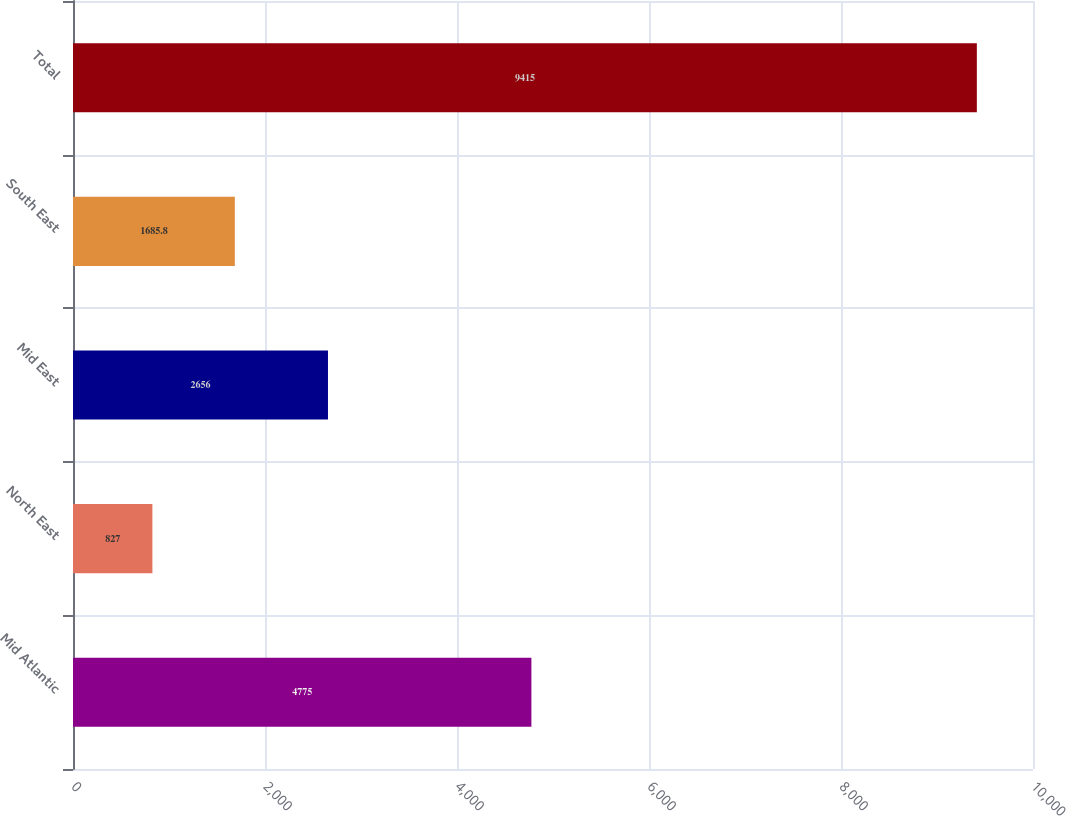Convert chart. <chart><loc_0><loc_0><loc_500><loc_500><bar_chart><fcel>Mid Atlantic<fcel>North East<fcel>Mid East<fcel>South East<fcel>Total<nl><fcel>4775<fcel>827<fcel>2656<fcel>1685.8<fcel>9415<nl></chart> 